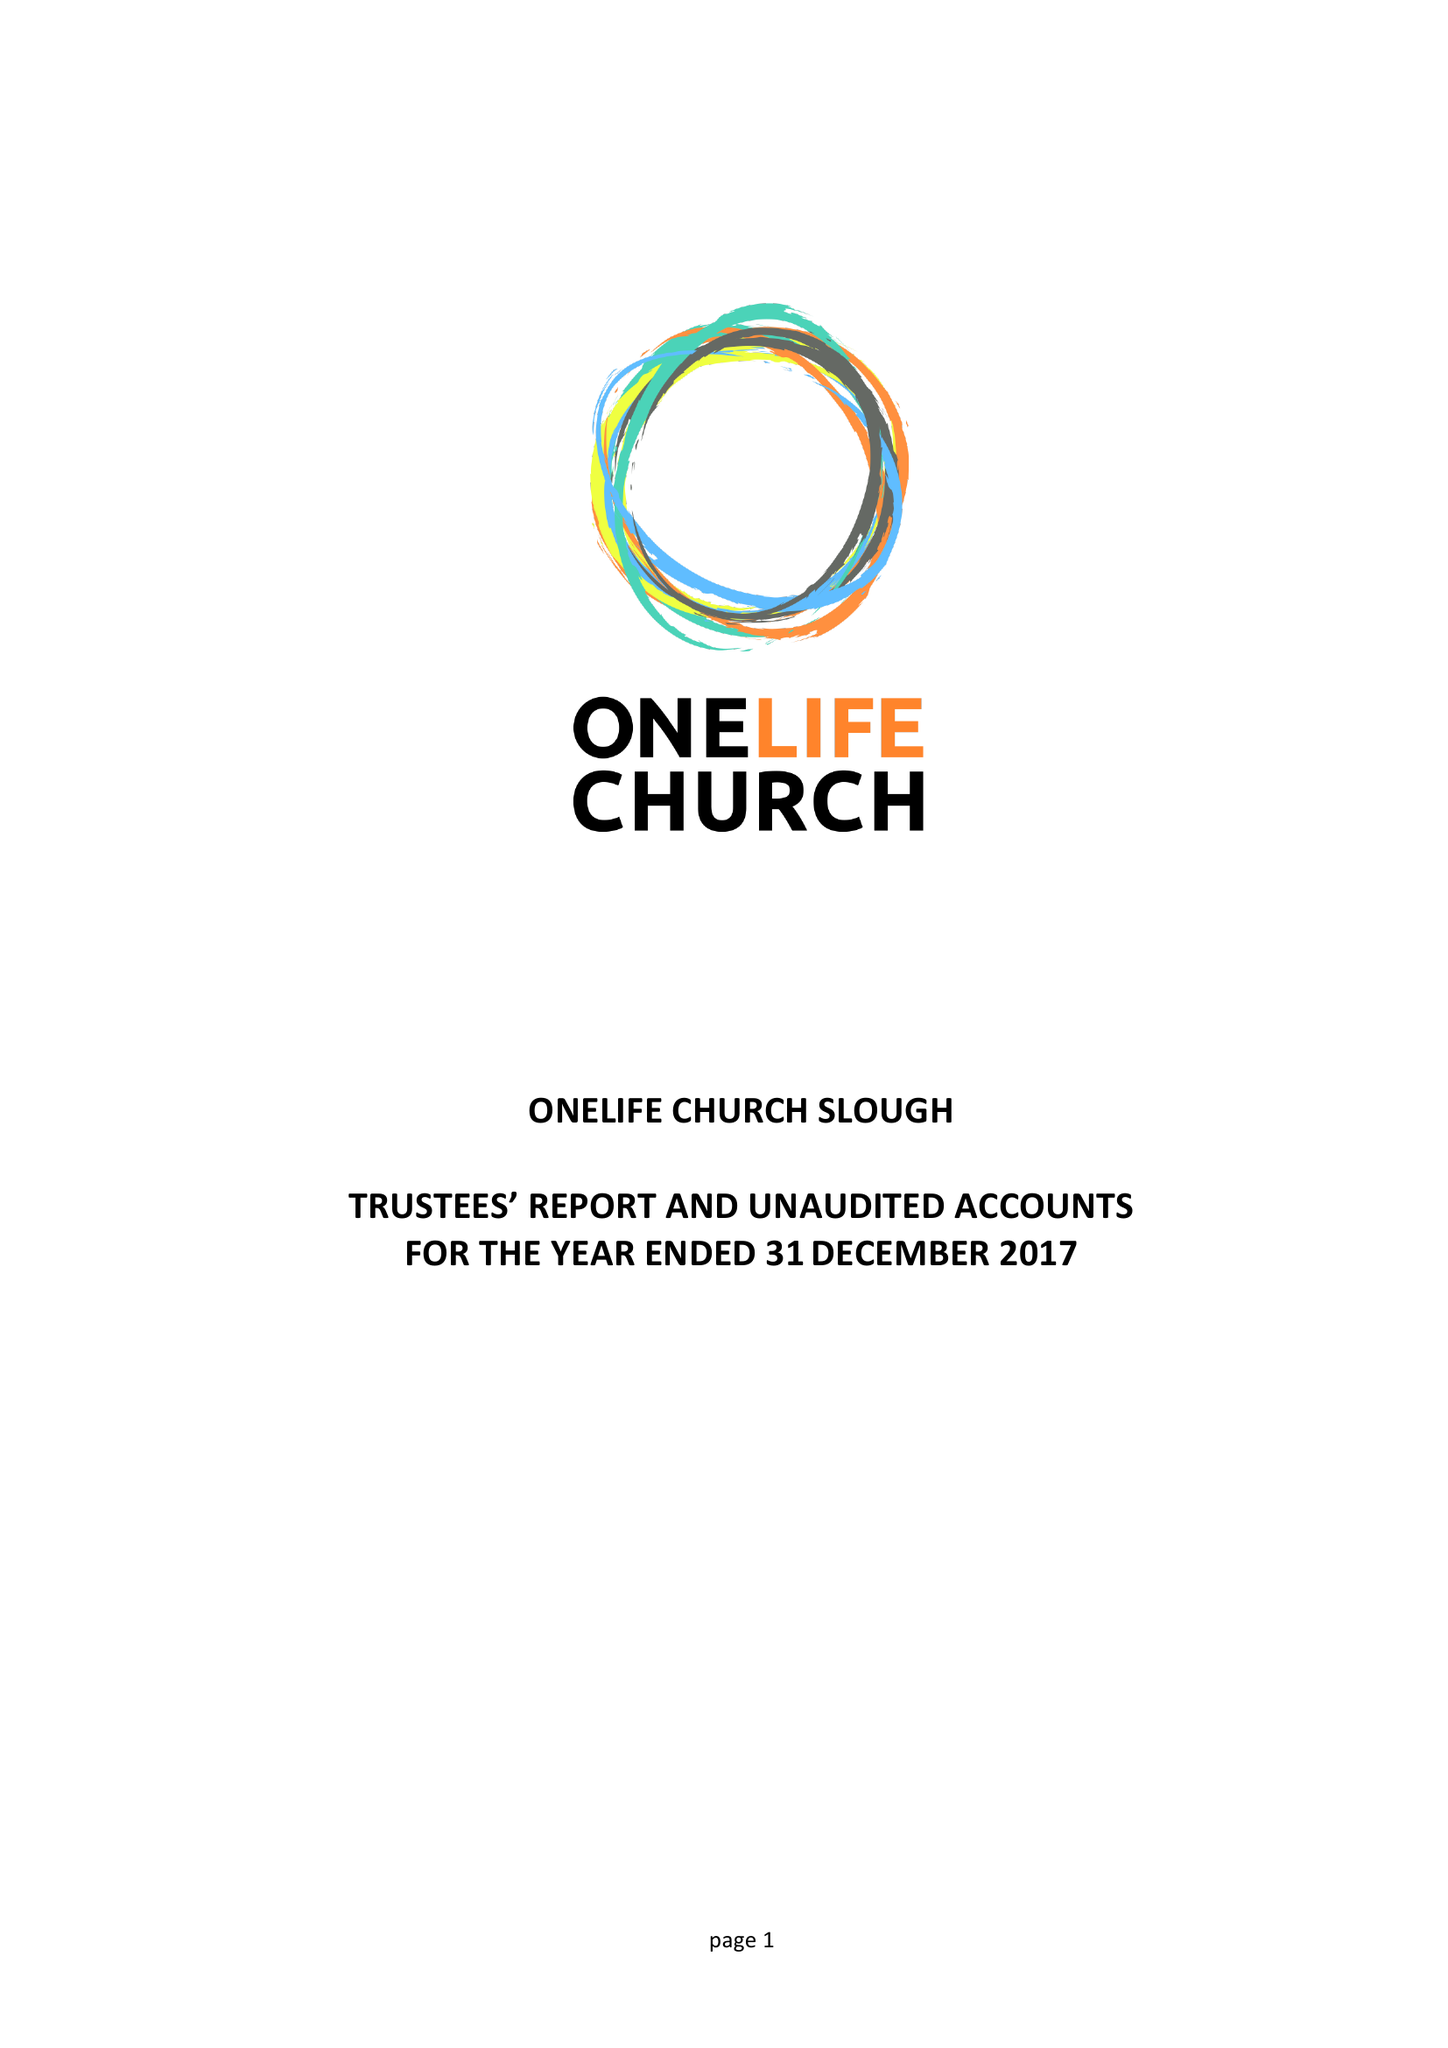What is the value for the income_annually_in_british_pounds?
Answer the question using a single word or phrase. 30104.00 